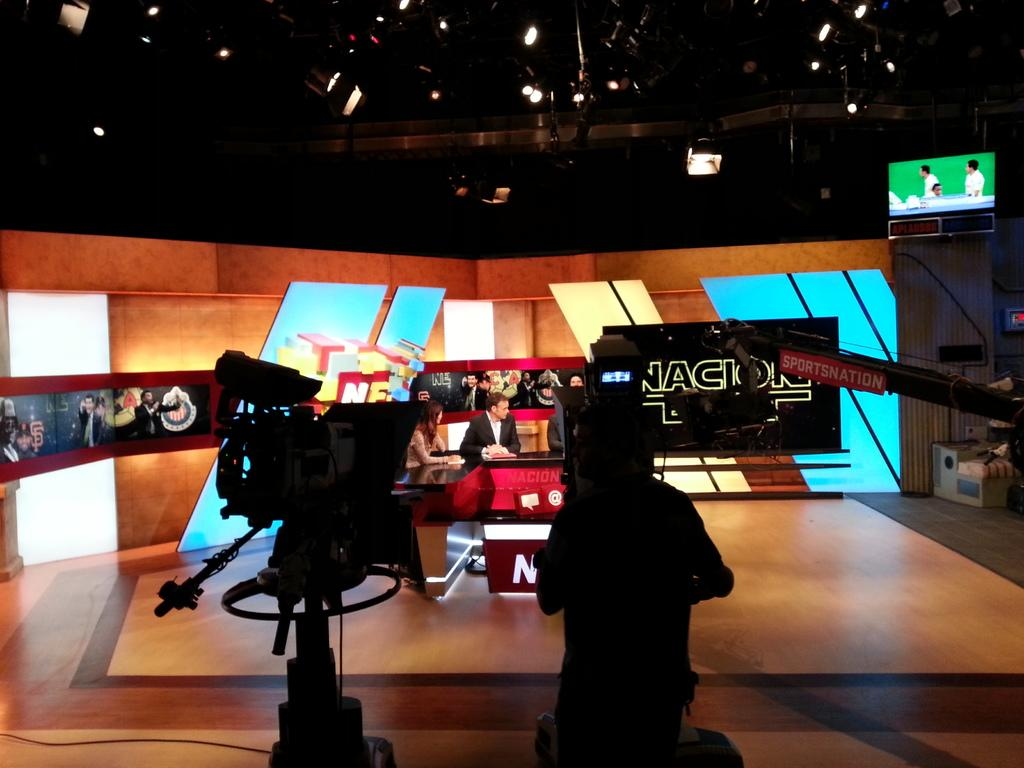<image>
Write a terse but informative summary of the picture. People giving the news in front of a camera that says SPORTSNATION on it. 